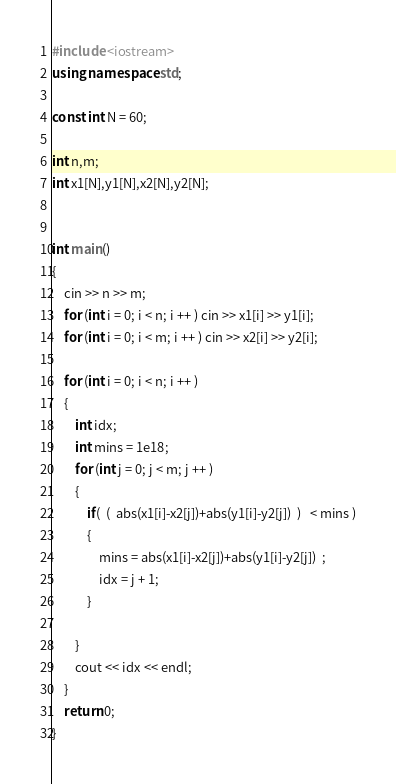<code> <loc_0><loc_0><loc_500><loc_500><_C++_>#include <iostream>
using namespace std;

const int N = 60;

int n,m;
int x1[N],y1[N],x2[N],y2[N];


int main()
{
    cin >> n >> m;
    for (int i = 0; i < n; i ++ ) cin >> x1[i] >> y1[i];
    for (int i = 0; i < m; i ++ ) cin >> x2[i] >> y2[i];

    for (int i = 0; i < n; i ++ )
    {
        int idx;
        int mins = 1e18;
        for (int j = 0; j < m; j ++ )
        {
            if(  (  abs(x1[i]-x2[j])+abs(y1[i]-y2[j])  )   < mins )
            {
                mins = abs(x1[i]-x2[j])+abs(y1[i]-y2[j])  ;
                idx = j + 1;
            }

        }
        cout << idx << endl;
    }
    return 0;
}

</code> 